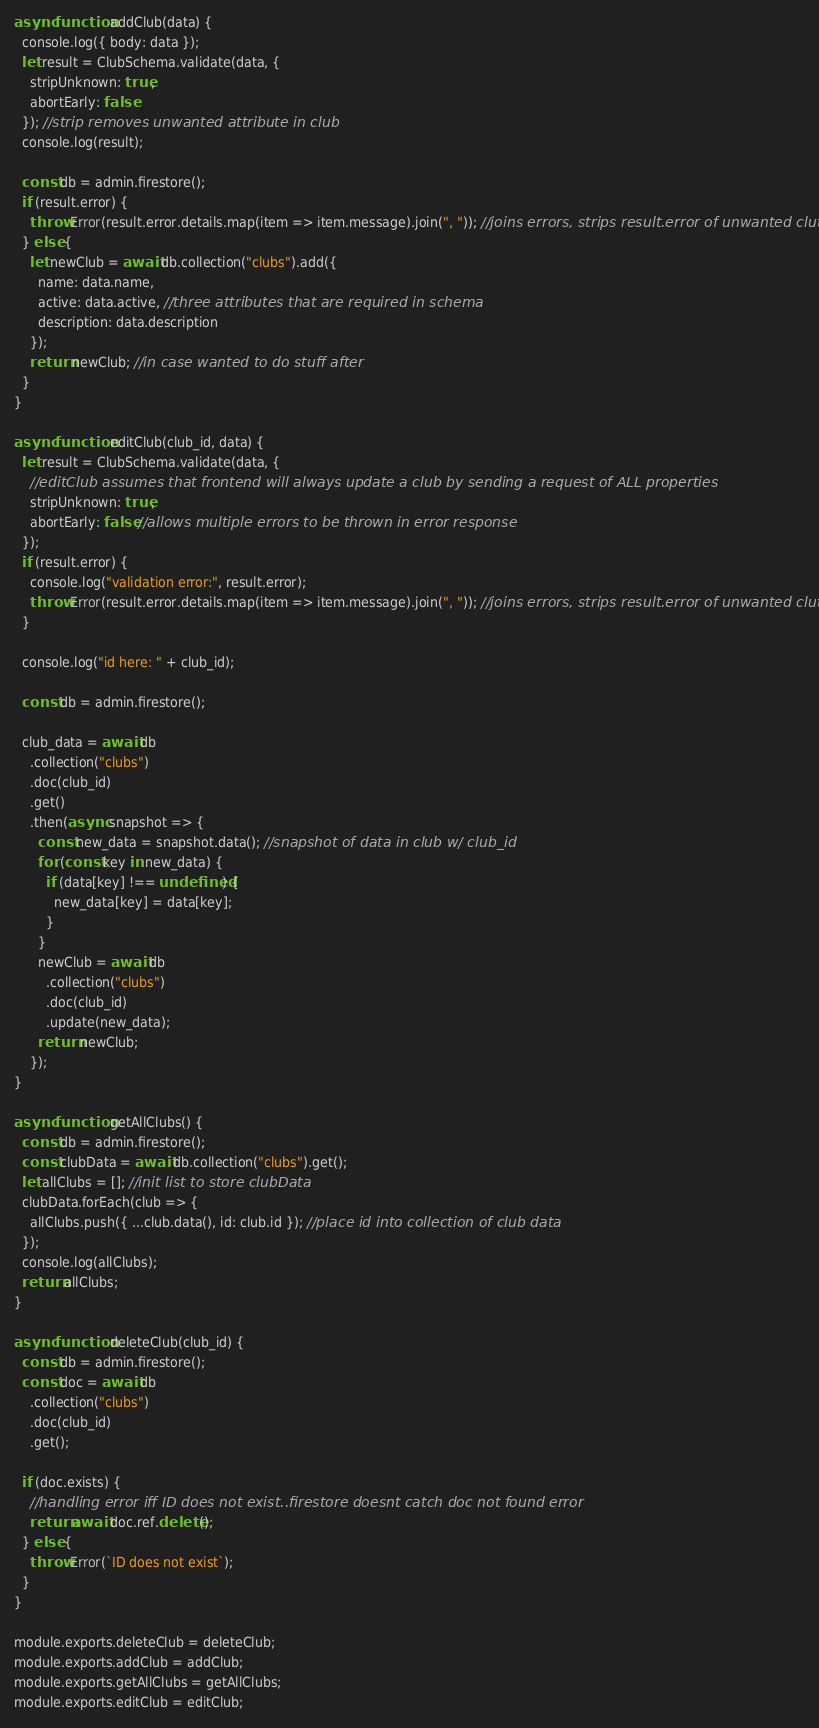<code> <loc_0><loc_0><loc_500><loc_500><_JavaScript_>async function addClub(data) {
  console.log({ body: data });
  let result = ClubSchema.validate(data, {
    stripUnknown: true,
    abortEarly: false
  }); //strip removes unwanted attribute in club
  console.log(result);

  const db = admin.firestore();
  if (result.error) {
    throw Error(result.error.details.map(item => item.message).join(", ")); //joins errors, strips result.error of unwanted clutter
  } else {
    let newClub = await db.collection("clubs").add({
      name: data.name,
      active: data.active, //three attributes that are required in schema
      description: data.description
    });
    return newClub; //in case wanted to do stuff after
  }
}

async function editClub(club_id, data) {
  let result = ClubSchema.validate(data, {
    //editClub assumes that frontend will always update a club by sending a request of ALL properties
    stripUnknown: true,
    abortEarly: false //allows multiple errors to be thrown in error response
  });
  if (result.error) {
    console.log("validation error:", result.error);
    throw Error(result.error.details.map(item => item.message).join(", ")); //joins errors, strips result.error of unwanted clutter
  }

  console.log("id here: " + club_id);

  const db = admin.firestore();

  club_data = await db
    .collection("clubs")
    .doc(club_id)
    .get()
    .then(async snapshot => {
      const new_data = snapshot.data(); //snapshot of data in club w/ club_id
      for (const key in new_data) {
        if (data[key] !== undefined) {
          new_data[key] = data[key];
        }
      }
      newClub = await db
        .collection("clubs")
        .doc(club_id)
        .update(new_data);
      return newClub;
    });
}

async function getAllClubs() {
  const db = admin.firestore();
  const clubData = await db.collection("clubs").get();
  let allClubs = []; //init list to store clubData
  clubData.forEach(club => {
    allClubs.push({ ...club.data(), id: club.id }); //place id into collection of club data
  });
  console.log(allClubs);
  return allClubs;
}

async function deleteClub(club_id) {
  const db = admin.firestore();
  const doc = await db
    .collection("clubs")
    .doc(club_id)
    .get();

  if (doc.exists) {
    //handling error iff ID does not exist..firestore doesnt catch doc not found error
    return await doc.ref.delete();
  } else {
    throw Error(`ID does not exist`);
  }
}

module.exports.deleteClub = deleteClub;
module.exports.addClub = addClub;
module.exports.getAllClubs = getAllClubs;
module.exports.editClub = editClub;
</code> 